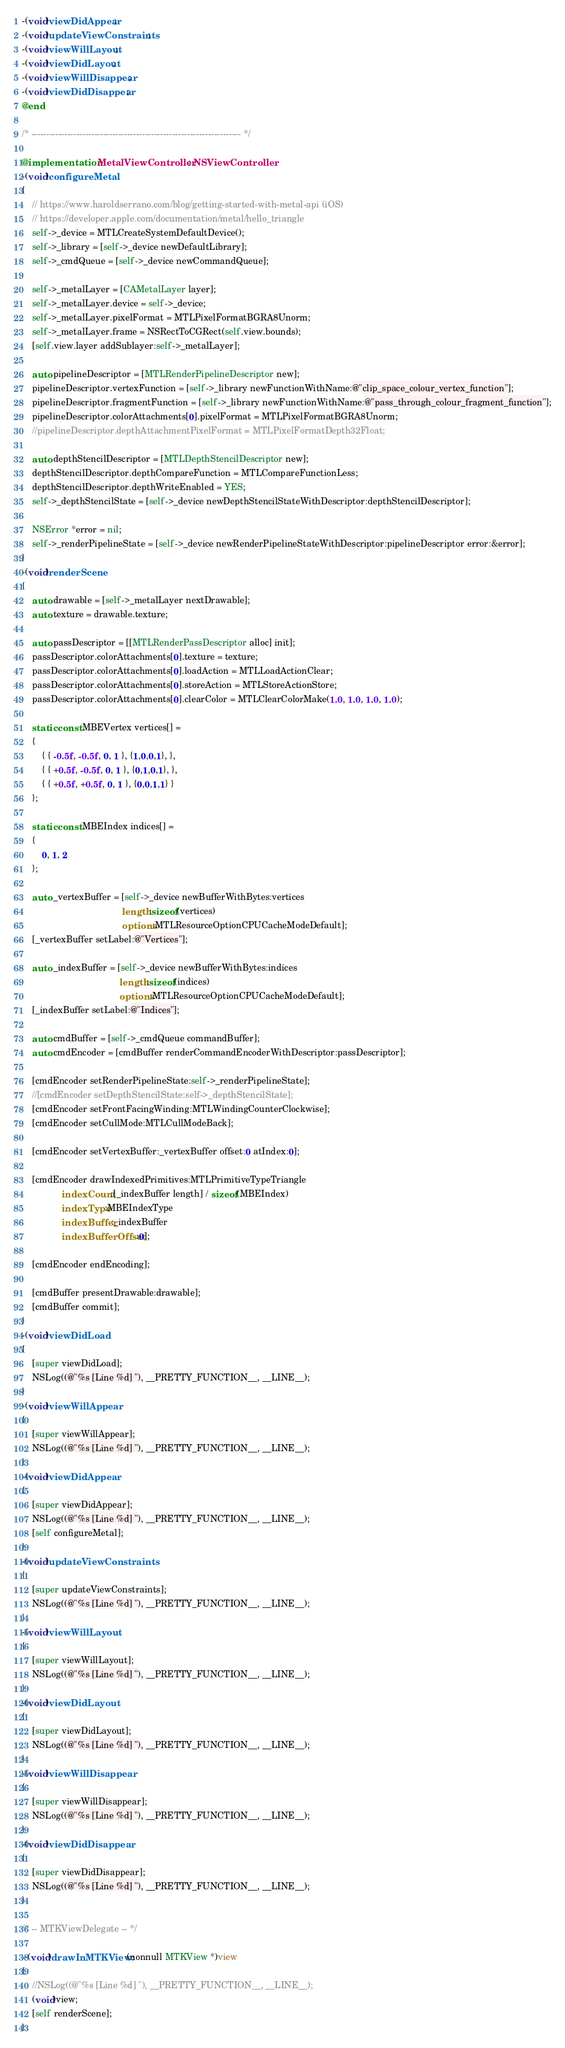<code> <loc_0><loc_0><loc_500><loc_500><_ObjectiveC_>-(void)viewDidAppear;
-(void)updateViewConstraints;
-(void)viewWillLayout;
-(void)viewDidLayout;
-(void)viewWillDisappear;
-(void)viewDidDisappear;
@end

/* ---------------------------------------------------------------------- */

@implementation MetalViewController : NSViewController
-(void)configureMetal
{
    // https://www.haroldserrano.com/blog/getting-started-with-metal-api (iOS)
    // https://developer.apple.com/documentation/metal/hello_triangle
    self->_device = MTLCreateSystemDefaultDevice();
    self->_library = [self->_device newDefaultLibrary];
    self->_cmdQueue = [self->_device newCommandQueue];

    self->_metalLayer = [CAMetalLayer layer];
    self->_metalLayer.device = self->_device;
    self->_metalLayer.pixelFormat = MTLPixelFormatBGRA8Unorm;
    self->_metalLayer.frame = NSRectToCGRect(self.view.bounds);
    [self.view.layer addSublayer:self->_metalLayer];

    auto pipelineDescriptor = [MTLRenderPipelineDescriptor new];
    pipelineDescriptor.vertexFunction = [self->_library newFunctionWithName:@"clip_space_colour_vertex_function"];
    pipelineDescriptor.fragmentFunction = [self->_library newFunctionWithName:@"pass_through_colour_fragment_function"];
    pipelineDescriptor.colorAttachments[0].pixelFormat = MTLPixelFormatBGRA8Unorm;
    //pipelineDescriptor.depthAttachmentPixelFormat = MTLPixelFormatDepth32Float;

    auto depthStencilDescriptor = [MTLDepthStencilDescriptor new];
    depthStencilDescriptor.depthCompareFunction = MTLCompareFunctionLess;
    depthStencilDescriptor.depthWriteEnabled = YES;
    self->_depthStencilState = [self->_device newDepthStencilStateWithDescriptor:depthStencilDescriptor];

    NSError *error = nil;
    self->_renderPipelineState = [self->_device newRenderPipelineStateWithDescriptor:pipelineDescriptor error:&error];
}
-(void)renderScene
{
    auto drawable = [self->_metalLayer nextDrawable];
    auto texture = drawable.texture;

    auto passDescriptor = [[MTLRenderPassDescriptor alloc] init];
    passDescriptor.colorAttachments[0].texture = texture;
    passDescriptor.colorAttachments[0].loadAction = MTLLoadActionClear;
    passDescriptor.colorAttachments[0].storeAction = MTLStoreActionStore;
    passDescriptor.colorAttachments[0].clearColor = MTLClearColorMake(1.0, 1.0, 1.0, 1.0);

    static const MBEVertex vertices[] =
    {
        { { -0.5f, -0.5f, 0, 1 }, {1,0,0,1}, },
        { { +0.5f, -0.5f, 0, 1 }, {0,1,0,1}, },
        { { +0.5f, +0.5f, 0, 1 }, {0,0,1,1} }
    };

    static const MBEIndex indices[] =
    {
        0, 1, 2
    };

    auto _vertexBuffer = [self->_device newBufferWithBytes:vertices
                                        length:sizeof(vertices)
                                        options:MTLResourceOptionCPUCacheModeDefault];
    [_vertexBuffer setLabel:@"Vertices"];

    auto _indexBuffer = [self->_device newBufferWithBytes:indices
                                       length:sizeof(indices)
                                       options:MTLResourceOptionCPUCacheModeDefault];
    [_indexBuffer setLabel:@"Indices"];

    auto cmdBuffer = [self->_cmdQueue commandBuffer];
    auto cmdEncoder = [cmdBuffer renderCommandEncoderWithDescriptor:passDescriptor];

    [cmdEncoder setRenderPipelineState:self->_renderPipelineState];
    //[cmdEncoder setDepthStencilState:self->_depthStencilState];
    [cmdEncoder setFrontFacingWinding:MTLWindingCounterClockwise];
    [cmdEncoder setCullMode:MTLCullModeBack];

    [cmdEncoder setVertexBuffer:_vertexBuffer offset:0 atIndex:0];

    [cmdEncoder drawIndexedPrimitives:MTLPrimitiveTypeTriangle
                indexCount:[_indexBuffer length] / sizeof(MBEIndex)
                indexType:MBEIndexType
                indexBuffer:_indexBuffer
                indexBufferOffset:0];

    [cmdEncoder endEncoding];

    [cmdBuffer presentDrawable:drawable];
    [cmdBuffer commit];
}
-(void)viewDidLoad
{
    [super viewDidLoad];
    NSLog((@"%s [Line %d] "), __PRETTY_FUNCTION__, __LINE__);
}
-(void)viewWillAppear
{
    [super viewWillAppear];
    NSLog((@"%s [Line %d] "), __PRETTY_FUNCTION__, __LINE__);
}
-(void)viewDidAppear
{
    [super viewDidAppear];
    NSLog((@"%s [Line %d] "), __PRETTY_FUNCTION__, __LINE__);
    [self configureMetal];
}
-(void)updateViewConstraints
{
    [super updateViewConstraints];
    NSLog((@"%s [Line %d] "), __PRETTY_FUNCTION__, __LINE__);
}
-(void)viewWillLayout
{
    [super viewWillLayout];
    NSLog((@"%s [Line %d] "), __PRETTY_FUNCTION__, __LINE__);
}
-(void)viewDidLayout
{
    [super viewDidLayout];
    NSLog((@"%s [Line %d] "), __PRETTY_FUNCTION__, __LINE__);
}
-(void)viewWillDisappear
{
    [super viewWillDisappear];
    NSLog((@"%s [Line %d] "), __PRETTY_FUNCTION__, __LINE__);
}
-(void)viewDidDisappear
{
    [super viewDidDisappear];
    NSLog((@"%s [Line %d] "), __PRETTY_FUNCTION__, __LINE__);
}

/* -- MTKViewDelegate -- */

- (void)drawInMTKView:(nonnull MTKView *)view
{
    //NSLog((@"%s [Line %d] "), __PRETTY_FUNCTION__, __LINE__);
    (void)view;
    [self renderScene];
}</code> 